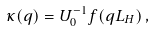Convert formula to latex. <formula><loc_0><loc_0><loc_500><loc_500>\kappa ( q ) = U _ { 0 } ^ { - 1 } f ( q L _ { H } ) \, ,</formula> 